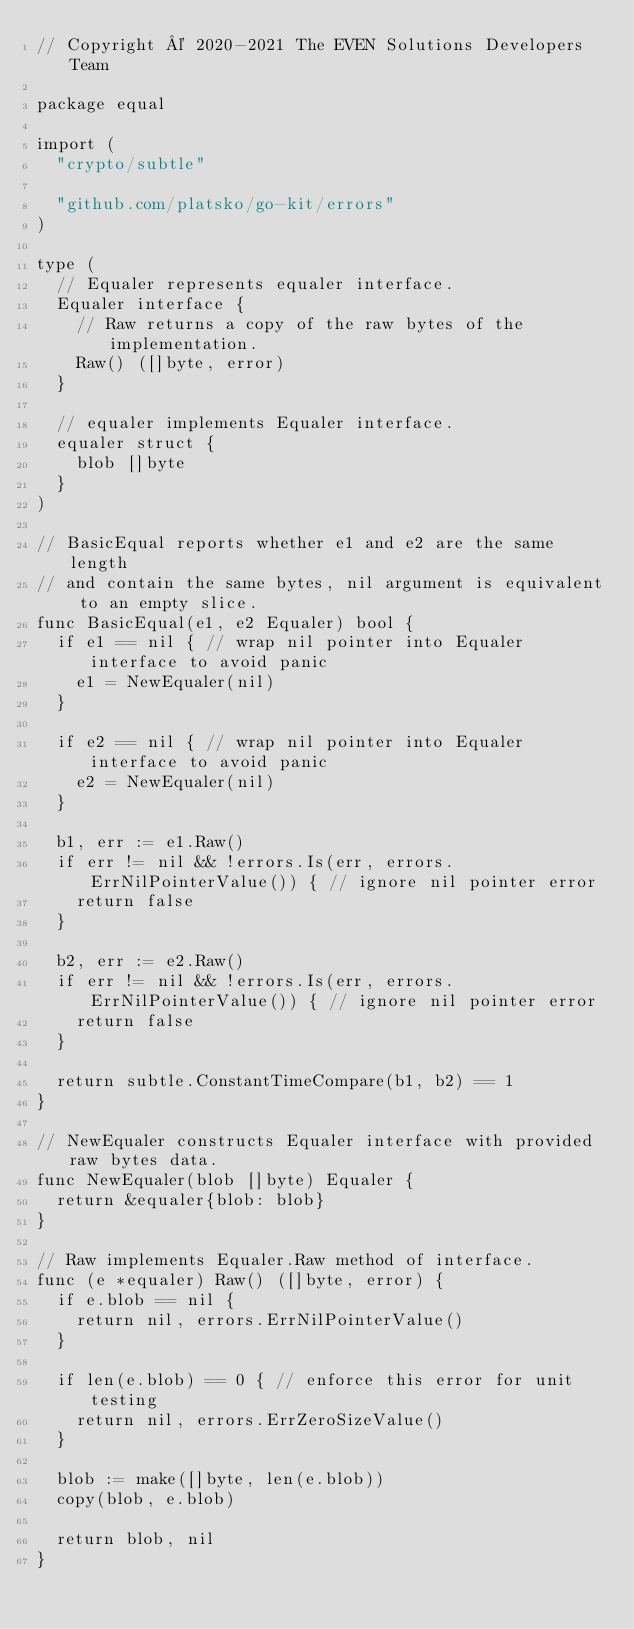<code> <loc_0><loc_0><loc_500><loc_500><_Go_>// Copyright © 2020-2021 The EVEN Solutions Developers Team

package equal

import (
	"crypto/subtle"

	"github.com/platsko/go-kit/errors"
)

type (
	// Equaler represents equaler interface.
	Equaler interface {
		// Raw returns a copy of the raw bytes of the implementation.
		Raw() ([]byte, error)
	}

	// equaler implements Equaler interface.
	equaler struct {
		blob []byte
	}
)

// BasicEqual reports whether e1 and e2 are the same length
// and contain the same bytes, nil argument is equivalent to an empty slice.
func BasicEqual(e1, e2 Equaler) bool {
	if e1 == nil { // wrap nil pointer into Equaler interface to avoid panic
		e1 = NewEqualer(nil)
	}

	if e2 == nil { // wrap nil pointer into Equaler interface to avoid panic
		e2 = NewEqualer(nil)
	}

	b1, err := e1.Raw()
	if err != nil && !errors.Is(err, errors.ErrNilPointerValue()) { // ignore nil pointer error
		return false
	}

	b2, err := e2.Raw()
	if err != nil && !errors.Is(err, errors.ErrNilPointerValue()) { // ignore nil pointer error
		return false
	}

	return subtle.ConstantTimeCompare(b1, b2) == 1
}

// NewEqualer constructs Equaler interface with provided raw bytes data.
func NewEqualer(blob []byte) Equaler {
	return &equaler{blob: blob}
}

// Raw implements Equaler.Raw method of interface.
func (e *equaler) Raw() ([]byte, error) {
	if e.blob == nil {
		return nil, errors.ErrNilPointerValue()
	}

	if len(e.blob) == 0 { // enforce this error for unit testing
		return nil, errors.ErrZeroSizeValue()
	}

	blob := make([]byte, len(e.blob))
	copy(blob, e.blob)

	return blob, nil
}
</code> 